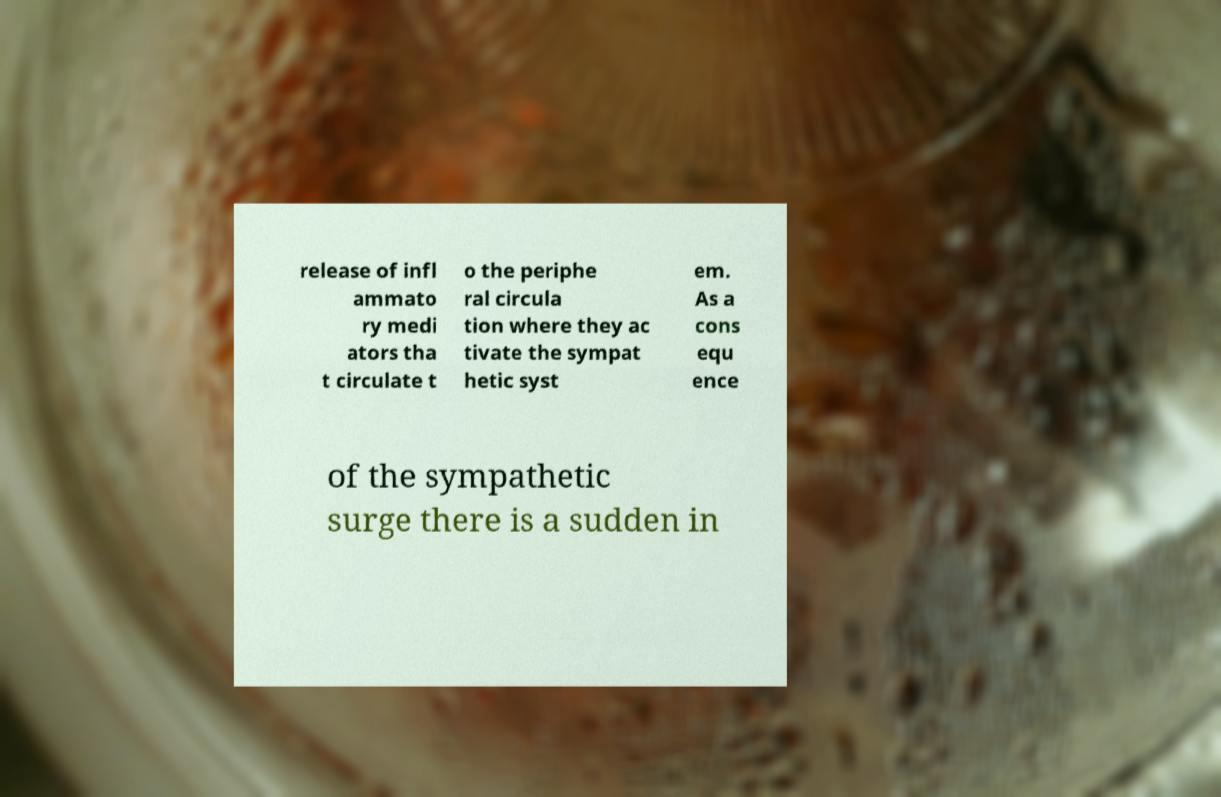What messages or text are displayed in this image? I need them in a readable, typed format. release of infl ammato ry medi ators tha t circulate t o the periphe ral circula tion where they ac tivate the sympat hetic syst em. As a cons equ ence of the sympathetic surge there is a sudden in 